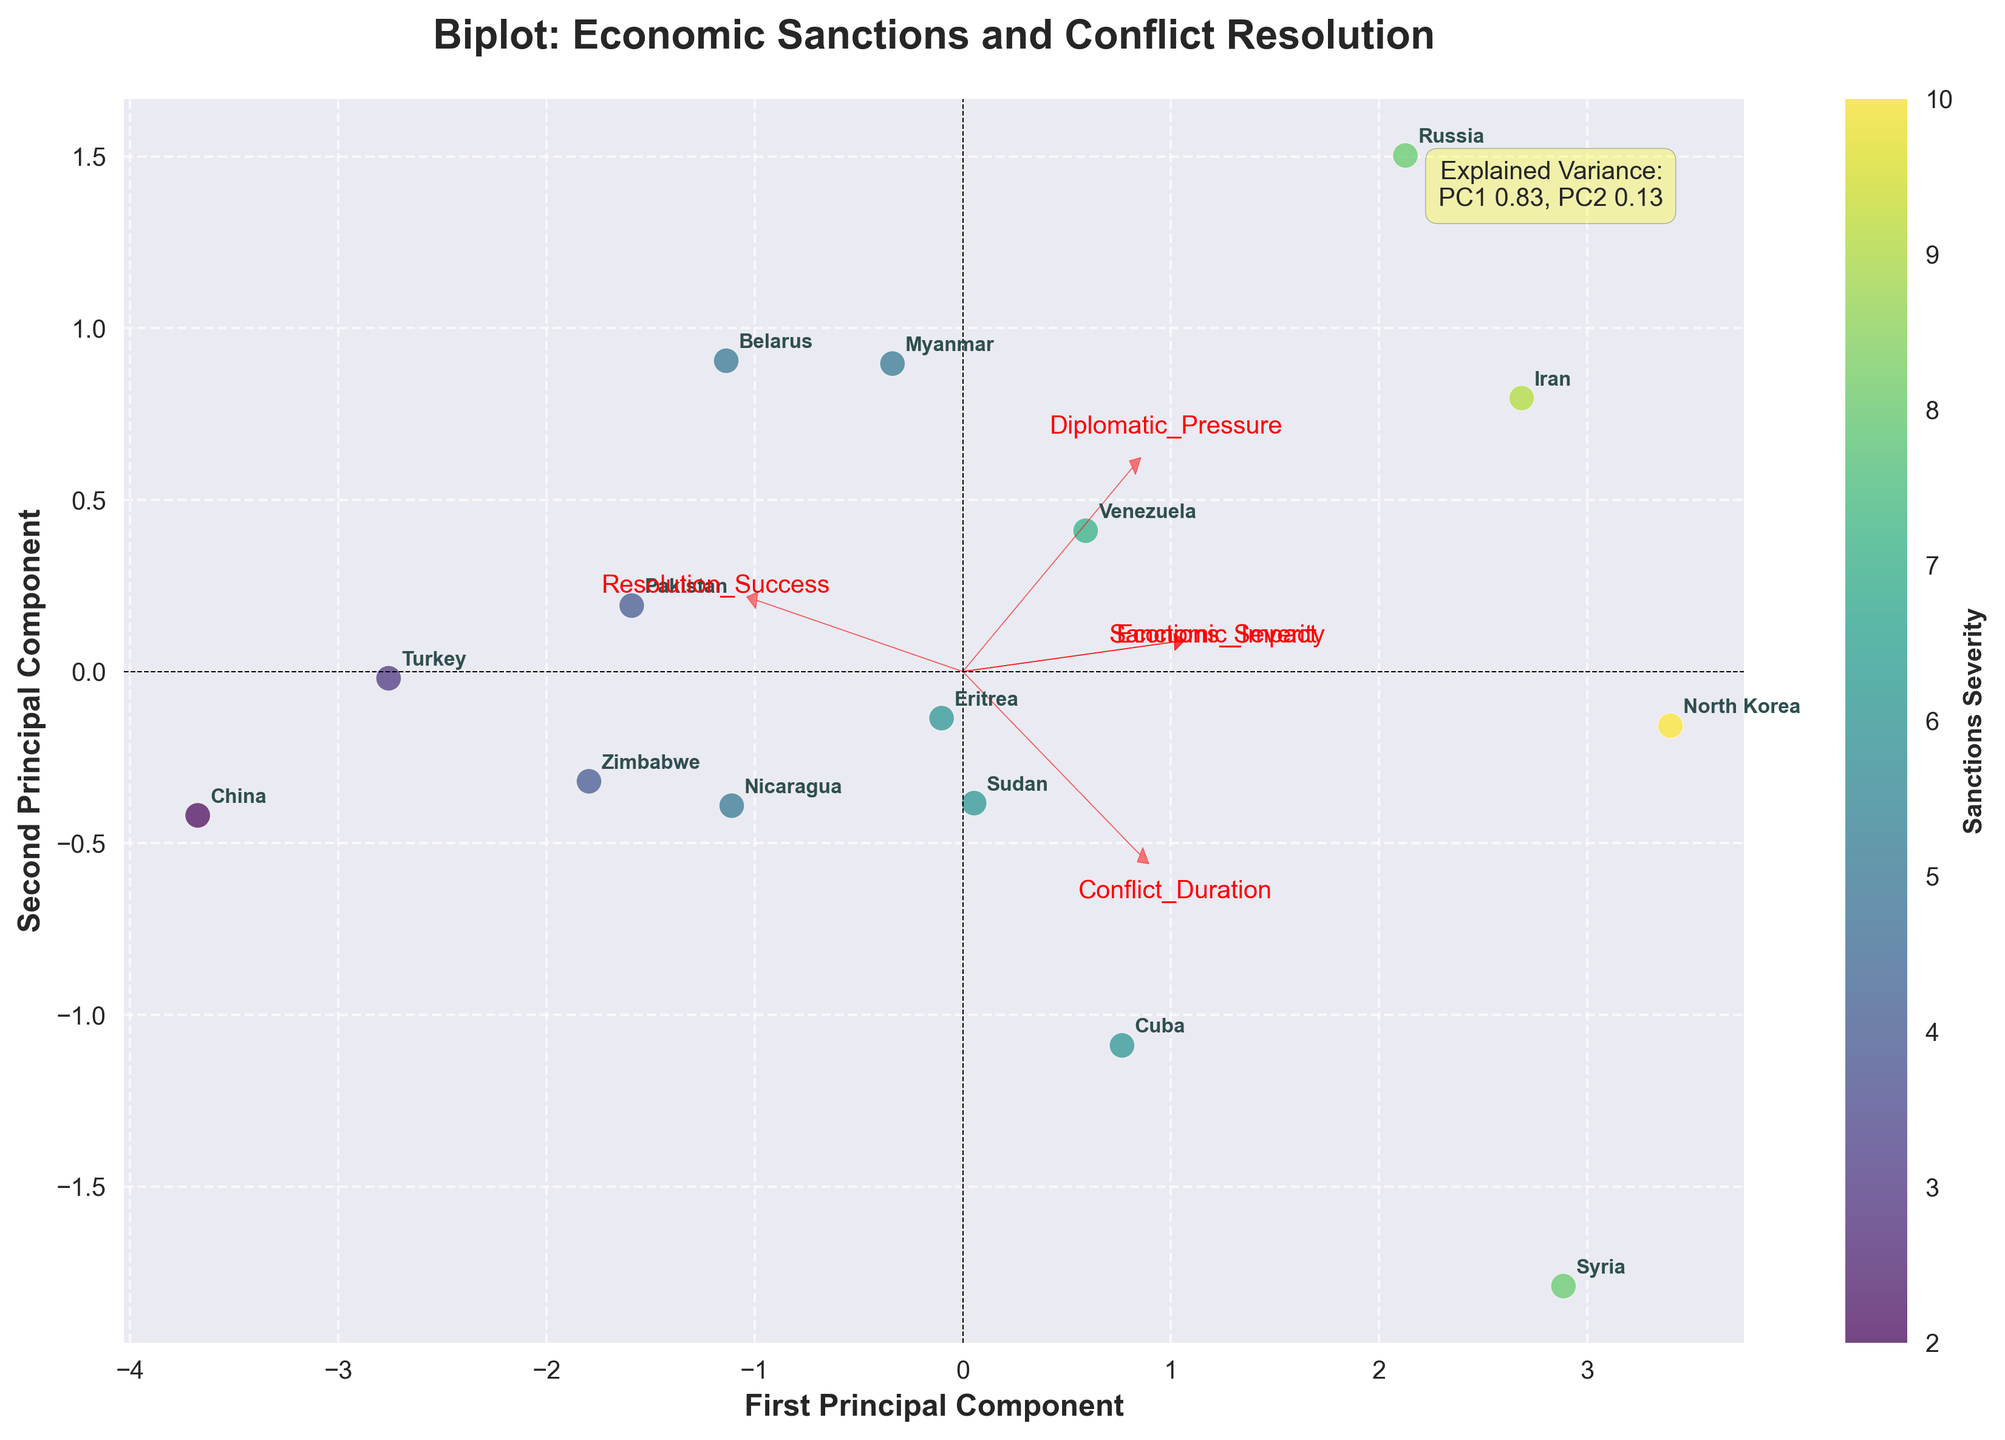How many countries are represented in the biplot? Count the unique country labels annotated on the biplot, which represent each data point.
Answer: 15 Which country shows the highest 'Resolution Success'? Find the position where the feature 'Resolution_Success' vector points and identify the closest country label.
Answer: China What is the relationship between 'Conflict Duration' and 'Economic Impact'? Observe the direction and proximity of the vectors for 'Conflict_Duration' and 'Economic_Impact'. Since they point in similar directions, a positive correlation is indicated.
Answer: Positive correlation Which countries are closest to each other on the biplot? Look for pairs of country labels that are near each other in the PCA space.
Answer: Turkey and China How much of the variance is explained by the first principal component (PC1)? Refer to the explained variance ratio text displayed on the biplot.
Answer: Approximately 0.40 Identify the vector pointing farthest from the origin and name the feature it represents. Determine which feature vector extends furthest from the (0,0) point on the biplot.
Answer: 'Conflict_Duration' Which country has the longest conflict duration according to the biplot? Identify the country label closest to the direction pointed by the 'Conflict_Duration' feature vector in the plotted space.
Answer: Syria Compare 'Economic Impact' in relation to 'Sanctions Severity'. Do they move in the same, opposite, or random directions? Analyze the directions of the 'Economic_Impact' and 'Sanctions_Severity' vectors. They point in nearly the same direction indicating a positive relationship.
Answer: Same direction What does the color bar represent in the biplot? Check the label of the color bar which often indicates what the color gradient stands for in the plot.
Answer: Sanctions Severity 